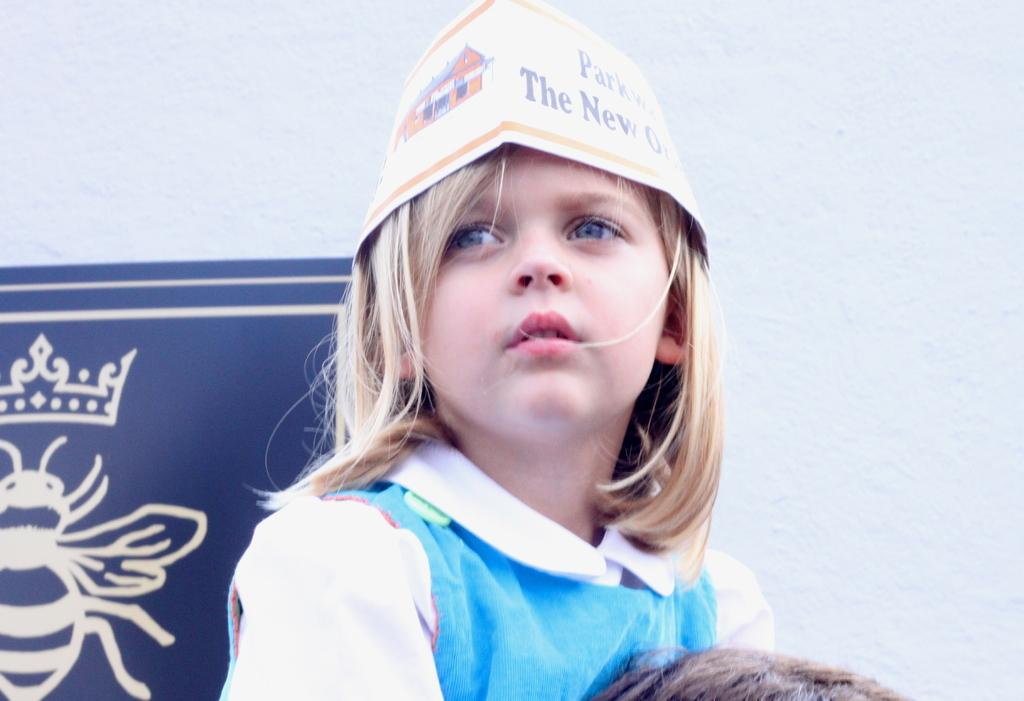<image>
Relay a brief, clear account of the picture shown. A girl in a paper hat with the words 'The New' on it . 